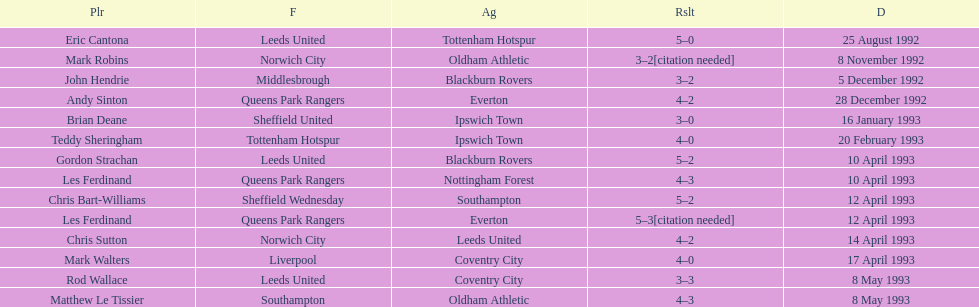What was the result of the match between queens park rangers and everton? 4-2. 